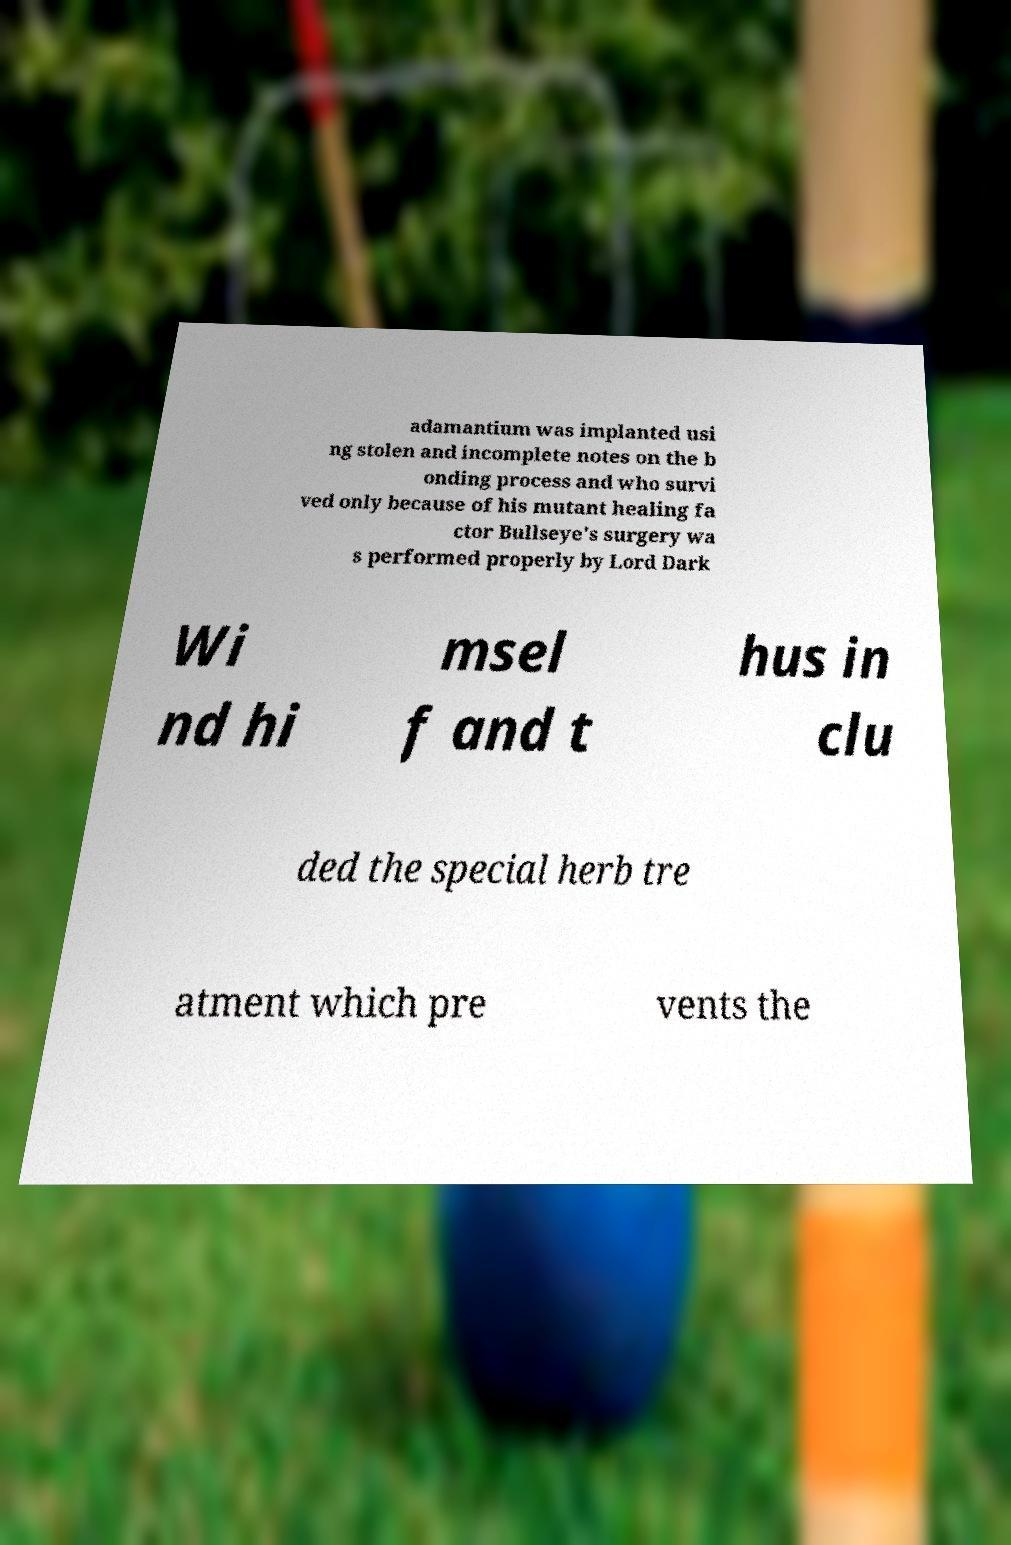Please read and relay the text visible in this image. What does it say? adamantium was implanted usi ng stolen and incomplete notes on the b onding process and who survi ved only because of his mutant healing fa ctor Bullseye's surgery wa s performed properly by Lord Dark Wi nd hi msel f and t hus in clu ded the special herb tre atment which pre vents the 